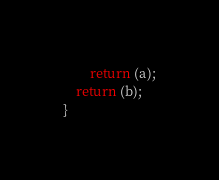<code> <loc_0><loc_0><loc_500><loc_500><_C_>		return (a);
	return (b);
}
</code> 